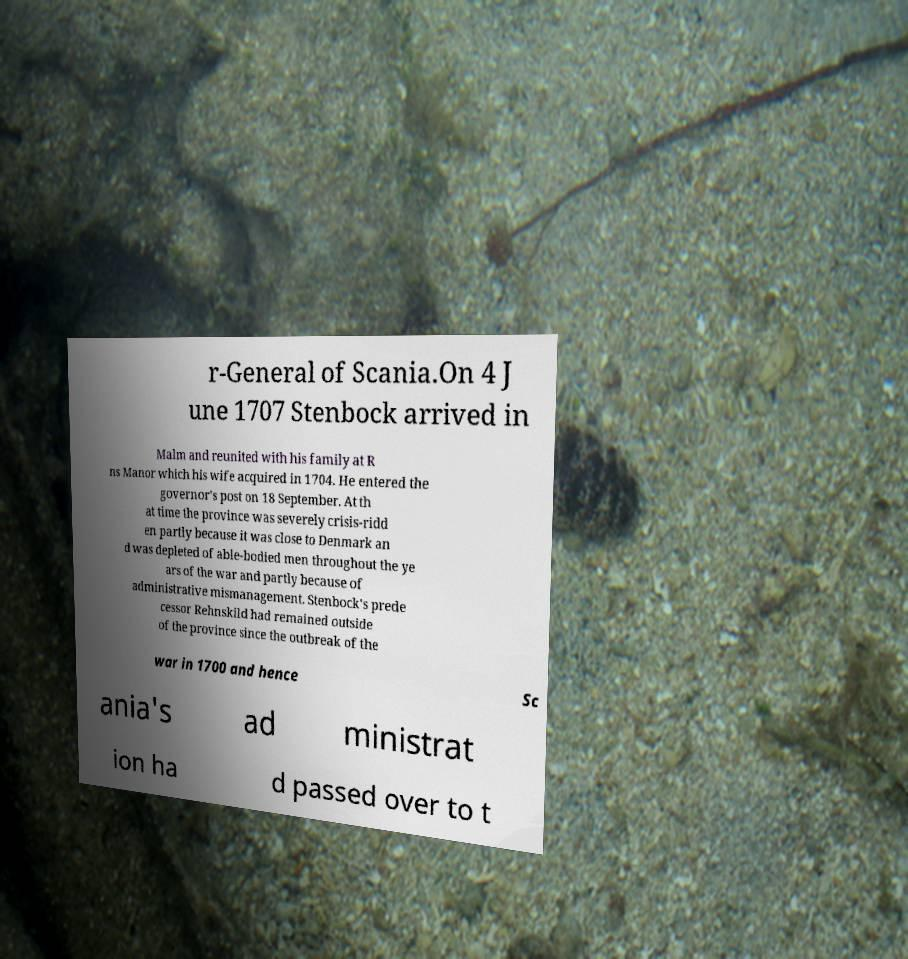Could you extract and type out the text from this image? r-General of Scania.On 4 J une 1707 Stenbock arrived in Malm and reunited with his family at R ns Manor which his wife acquired in 1704. He entered the governor's post on 18 September. At th at time the province was severely crisis-ridd en partly because it was close to Denmark an d was depleted of able-bodied men throughout the ye ars of the war and partly because of administrative mismanagement. Stenbock's prede cessor Rehnskild had remained outside of the province since the outbreak of the war in 1700 and hence Sc ania's ad ministrat ion ha d passed over to t 